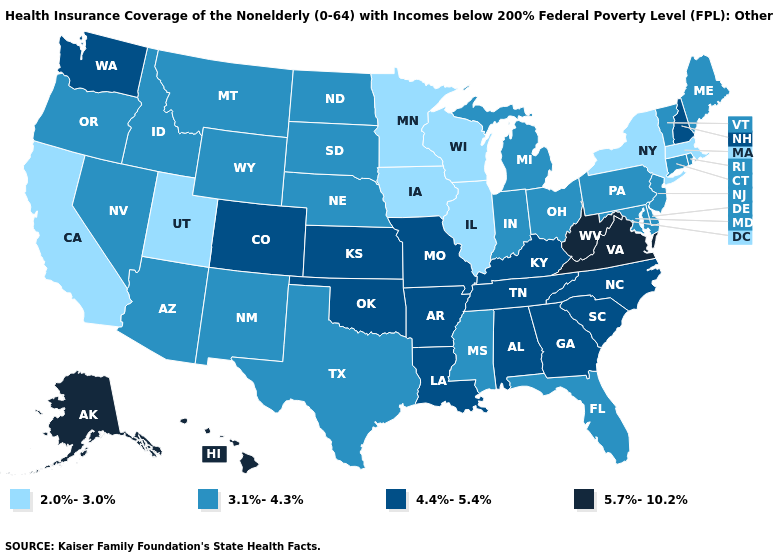Name the states that have a value in the range 4.4%-5.4%?
Be succinct. Alabama, Arkansas, Colorado, Georgia, Kansas, Kentucky, Louisiana, Missouri, New Hampshire, North Carolina, Oklahoma, South Carolina, Tennessee, Washington. Does Connecticut have a higher value than Delaware?
Concise answer only. No. What is the value of Minnesota?
Be succinct. 2.0%-3.0%. Name the states that have a value in the range 5.7%-10.2%?
Answer briefly. Alaska, Hawaii, Virginia, West Virginia. Name the states that have a value in the range 4.4%-5.4%?
Keep it brief. Alabama, Arkansas, Colorado, Georgia, Kansas, Kentucky, Louisiana, Missouri, New Hampshire, North Carolina, Oklahoma, South Carolina, Tennessee, Washington. Does the map have missing data?
Write a very short answer. No. Does the first symbol in the legend represent the smallest category?
Answer briefly. Yes. Does Alabama have a lower value than Kansas?
Write a very short answer. No. Name the states that have a value in the range 4.4%-5.4%?
Write a very short answer. Alabama, Arkansas, Colorado, Georgia, Kansas, Kentucky, Louisiana, Missouri, New Hampshire, North Carolina, Oklahoma, South Carolina, Tennessee, Washington. What is the highest value in the USA?
Write a very short answer. 5.7%-10.2%. Which states have the lowest value in the Northeast?
Give a very brief answer. Massachusetts, New York. What is the value of Alaska?
Write a very short answer. 5.7%-10.2%. Which states have the lowest value in the USA?
Keep it brief. California, Illinois, Iowa, Massachusetts, Minnesota, New York, Utah, Wisconsin. Is the legend a continuous bar?
Be succinct. No. What is the value of Utah?
Write a very short answer. 2.0%-3.0%. 